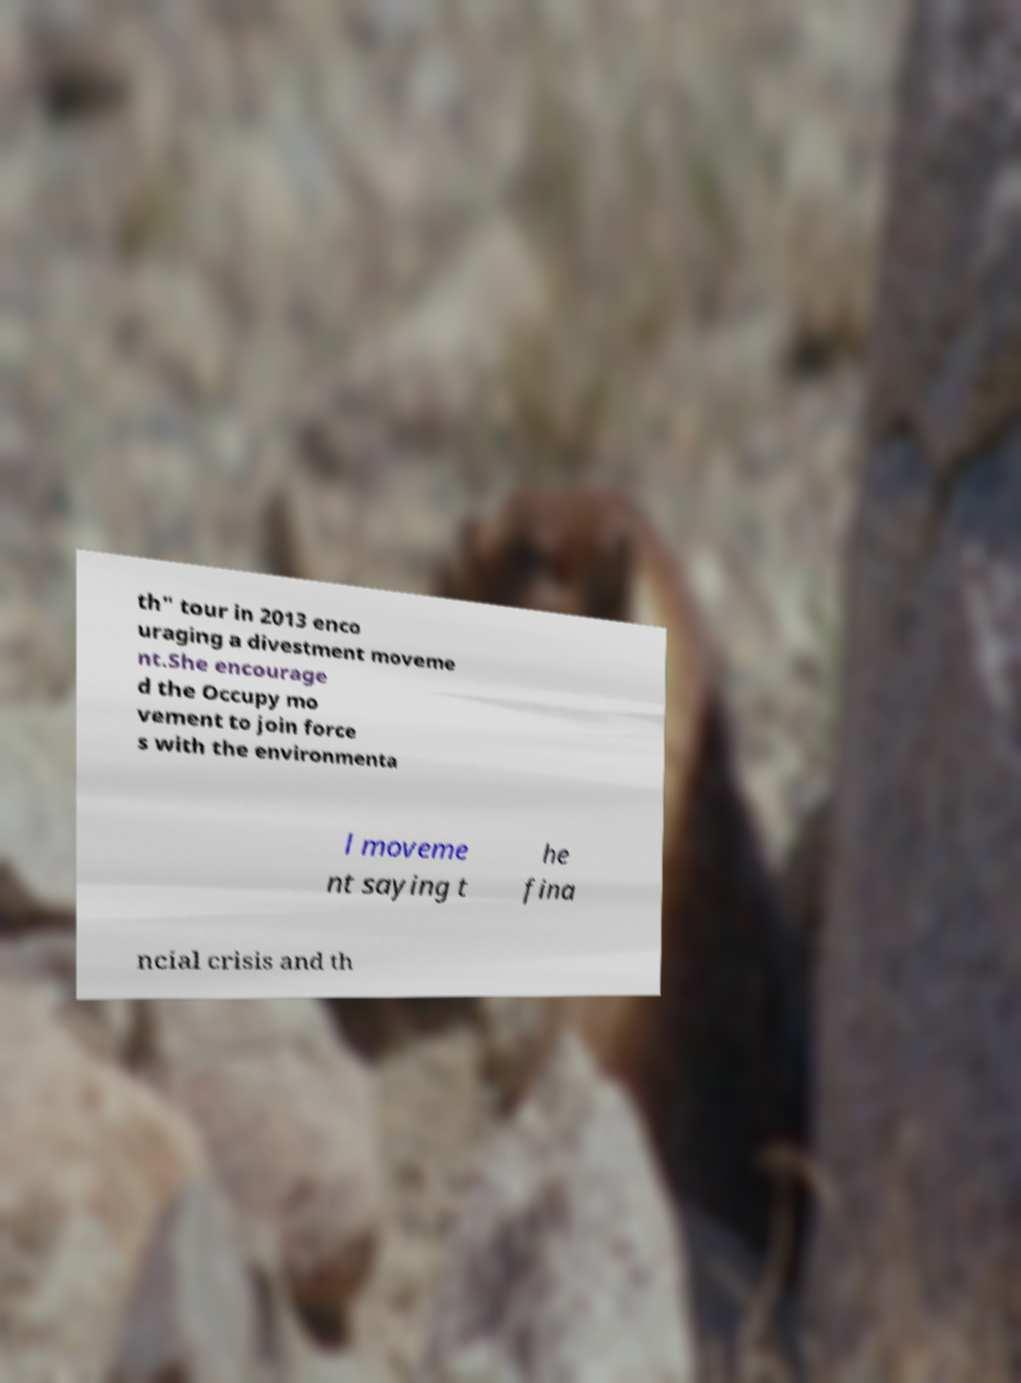There's text embedded in this image that I need extracted. Can you transcribe it verbatim? th" tour in 2013 enco uraging a divestment moveme nt.She encourage d the Occupy mo vement to join force s with the environmenta l moveme nt saying t he fina ncial crisis and th 